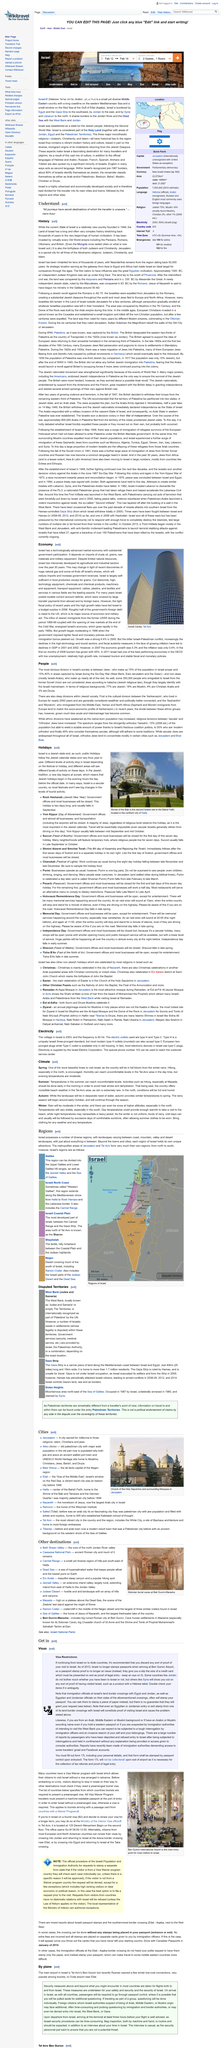Point out several critical features in this image. Most electronic devices in Israel use Type C plugs. The picture depicts a Jewish temple. According to Jewish tradition, a new day begins at sunset. The voltage of electricity in Israel is 230V. The title of the article is 'Holidays.' 